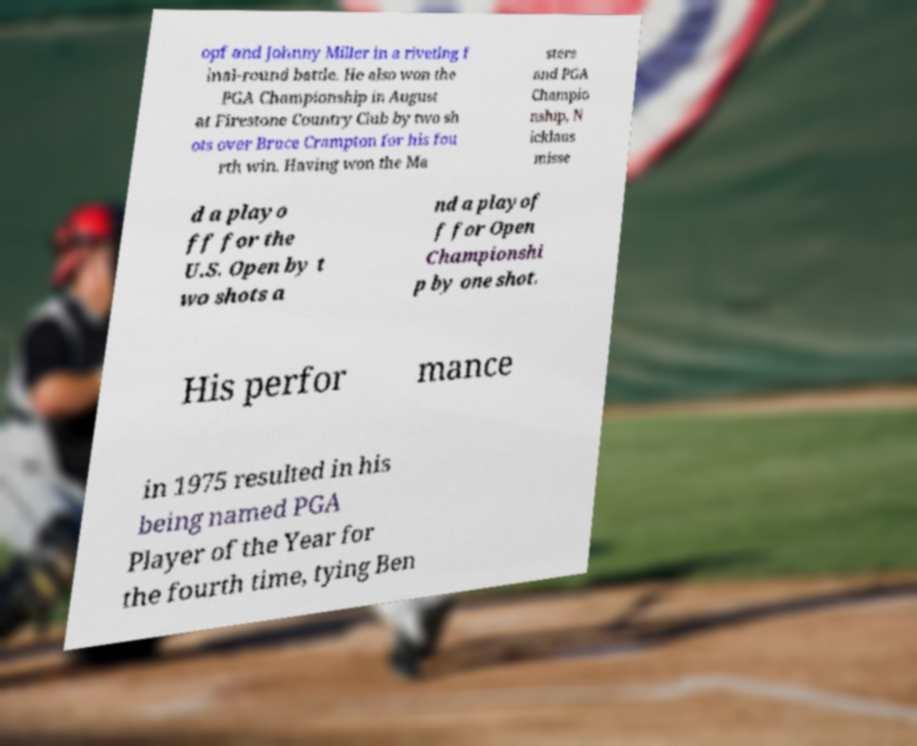Could you extract and type out the text from this image? opf and Johnny Miller in a riveting f inal-round battle. He also won the PGA Championship in August at Firestone Country Club by two sh ots over Bruce Crampton for his fou rth win. Having won the Ma sters and PGA Champio nship, N icklaus misse d a playo ff for the U.S. Open by t wo shots a nd a playof f for Open Championshi p by one shot. His perfor mance in 1975 resulted in his being named PGA Player of the Year for the fourth time, tying Ben 